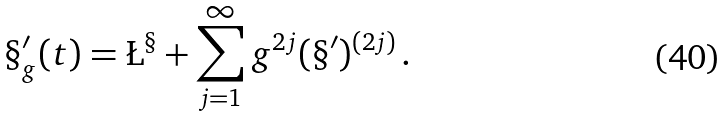<formula> <loc_0><loc_0><loc_500><loc_500>\S _ { g } ^ { \prime } ( t ) = \L ^ { \S } + \sum _ { j = 1 } ^ { \infty } g ^ { 2 j } ( \S ^ { \prime } ) ^ { ( 2 j ) } \, .</formula> 